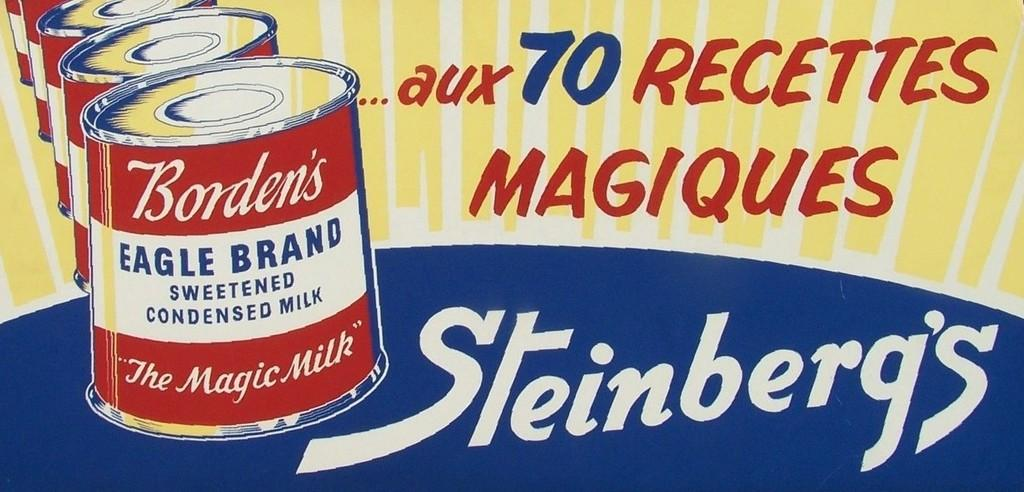<image>
Give a short and clear explanation of the subsequent image. An ad in another language for Borden's Eagle Brand Condensed Milk. 